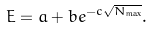Convert formula to latex. <formula><loc_0><loc_0><loc_500><loc_500>E = a + b e ^ { - c \sqrt { N _ { \max } } } .</formula> 